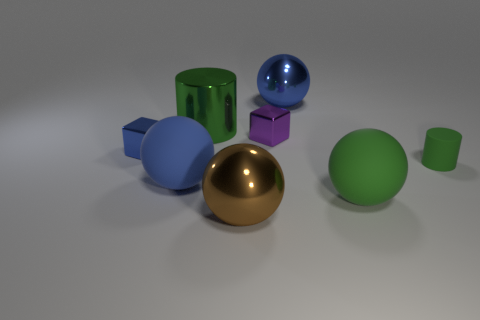Add 1 big brown spheres. How many objects exist? 9 Subtract all cylinders. How many objects are left? 6 Subtract 0 purple cylinders. How many objects are left? 8 Subtract all brown shiny spheres. Subtract all blue shiny things. How many objects are left? 5 Add 8 small cylinders. How many small cylinders are left? 9 Add 7 tiny purple rubber objects. How many tiny purple rubber objects exist? 7 